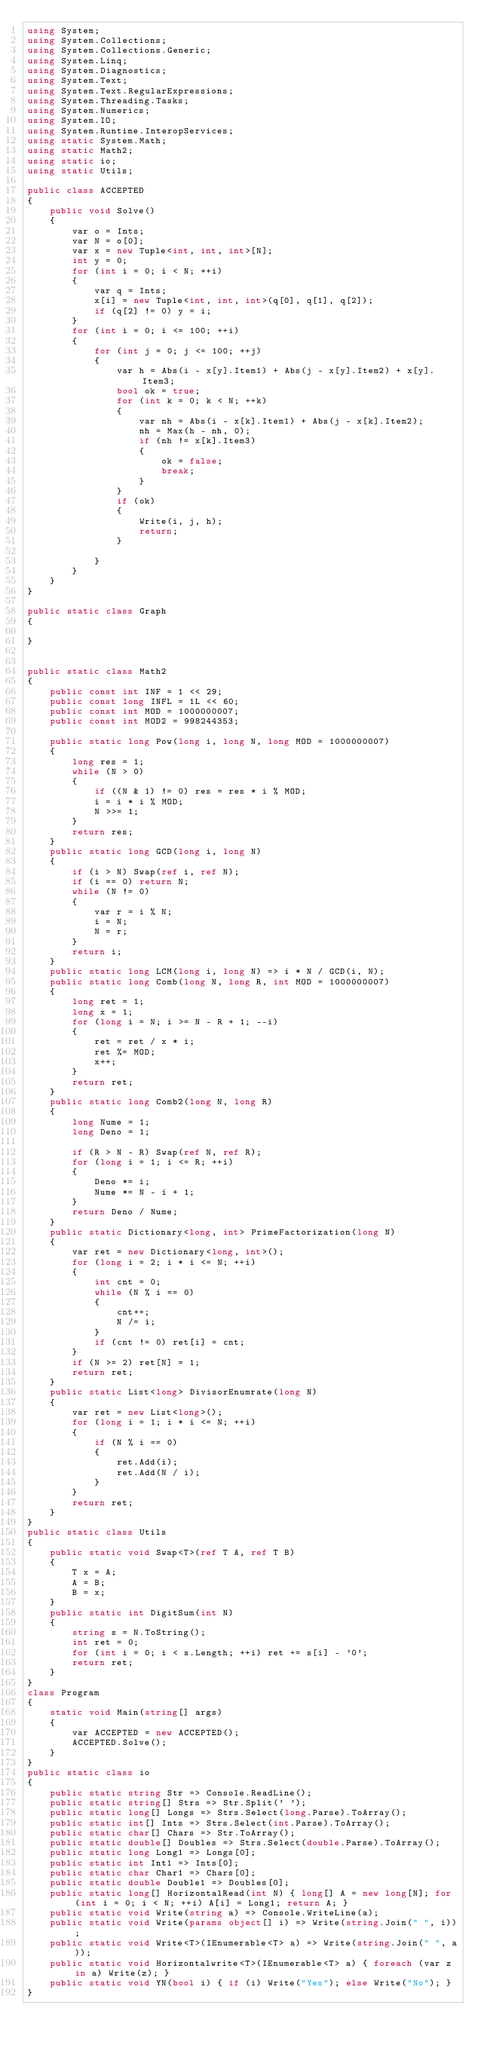Convert code to text. <code><loc_0><loc_0><loc_500><loc_500><_C#_>using System;
using System.Collections;
using System.Collections.Generic;
using System.Linq;
using System.Diagnostics;
using System.Text;
using System.Text.RegularExpressions;
using System.Threading.Tasks;
using System.Numerics;
using System.IO;
using System.Runtime.InteropServices;
using static System.Math;
using static Math2;
using static io;
using static Utils;

public class ACCEPTED
{
    public void Solve()
    {
        var o = Ints;
        var N = o[0];
        var x = new Tuple<int, int, int>[N];
        int y = 0;
        for (int i = 0; i < N; ++i)
        {
            var q = Ints;
            x[i] = new Tuple<int, int, int>(q[0], q[1], q[2]);
            if (q[2] != 0) y = i;
        }
        for (int i = 0; i <= 100; ++i)
        {
            for (int j = 0; j <= 100; ++j)
            {
                var h = Abs(i - x[y].Item1) + Abs(j - x[y].Item2) + x[y].Item3;
                bool ok = true;
                for (int k = 0; k < N; ++k)
                {
                    var nh = Abs(i - x[k].Item1) + Abs(j - x[k].Item2);
                    nh = Max(h - nh, 0);
                    if (nh != x[k].Item3)
                    {
                        ok = false;
                        break;
                    }
                }
                if (ok)
                {
                    Write(i, j, h);
                    return;
                }

            }
        }
    }
}

public static class Graph
{

}


public static class Math2
{
    public const int INF = 1 << 29;
    public const long INFL = 1L << 60;
    public const int MOD = 1000000007;
    public const int MOD2 = 998244353;

    public static long Pow(long i, long N, long MOD = 1000000007)
    {
        long res = 1;
        while (N > 0)
        {
            if ((N & 1) != 0) res = res * i % MOD;
            i = i * i % MOD;
            N >>= 1;
        }
        return res;
    }
    public static long GCD(long i, long N)
    {
        if (i > N) Swap(ref i, ref N);
        if (i == 0) return N;
        while (N != 0)
        {
            var r = i % N;
            i = N;
            N = r;
        }
        return i;
    }
    public static long LCM(long i, long N) => i * N / GCD(i, N);
    public static long Comb(long N, long R, int MOD = 1000000007)
    {
        long ret = 1;
        long x = 1;
        for (long i = N; i >= N - R + 1; --i)
        {
            ret = ret / x * i;
            ret %= MOD;
            x++;
        }
        return ret;
    }
    public static long Comb2(long N, long R)
    {
        long Nume = 1;
        long Deno = 1;

        if (R > N - R) Swap(ref N, ref R);
        for (long i = 1; i <= R; ++i)
        {
            Deno *= i;
            Nume *= N - i + 1;
        }
        return Deno / Nume;
    }
    public static Dictionary<long, int> PrimeFactorization(long N)
    {
        var ret = new Dictionary<long, int>();
        for (long i = 2; i * i <= N; ++i)
        {
            int cnt = 0;
            while (N % i == 0)
            {
                cnt++;
                N /= i;
            }
            if (cnt != 0) ret[i] = cnt;
        }
        if (N >= 2) ret[N] = 1;
        return ret;
    }
    public static List<long> DivisorEnumrate(long N)
    {
        var ret = new List<long>();
        for (long i = 1; i * i <= N; ++i)
        {
            if (N % i == 0)
            {
                ret.Add(i);
                ret.Add(N / i);
            }
        }
        return ret;
    }
}
public static class Utils
{
    public static void Swap<T>(ref T A, ref T B)
    {
        T x = A;
        A = B;
        B = x;
    }
    public static int DigitSum(int N)
    {
        string s = N.ToString();
        int ret = 0;
        for (int i = 0; i < s.Length; ++i) ret += s[i] - '0';
        return ret;
    }
}
class Program
{
    static void Main(string[] args)
    {
        var ACCEPTED = new ACCEPTED();
        ACCEPTED.Solve();
    }
}
public static class io
{
    public static string Str => Console.ReadLine();
    public static string[] Strs => Str.Split(' ');
    public static long[] Longs => Strs.Select(long.Parse).ToArray();
    public static int[] Ints => Strs.Select(int.Parse).ToArray();
    public static char[] Chars => Str.ToArray();
    public static double[] Doubles => Strs.Select(double.Parse).ToArray();
    public static long Long1 => Longs[0];
    public static int Int1 => Ints[0];
    public static char Char1 => Chars[0];
    public static double Double1 => Doubles[0];
    public static long[] HorizontalRead(int N) { long[] A = new long[N]; for (int i = 0; i < N; ++i) A[i] = Long1; return A; }
    public static void Write(string a) => Console.WriteLine(a);
    public static void Write(params object[] i) => Write(string.Join(" ", i));
    public static void Write<T>(IEnumerable<T> a) => Write(string.Join(" ", a));
    public static void Horizontalwrite<T>(IEnumerable<T> a) { foreach (var z in a) Write(z); }
    public static void YN(bool i) { if (i) Write("Yes"); else Write("No"); }
}
</code> 